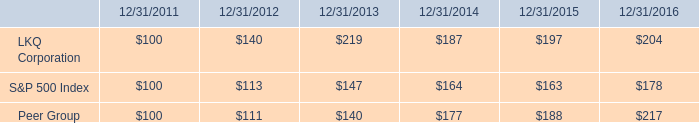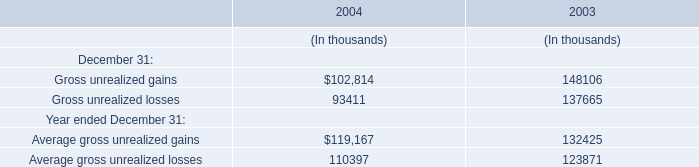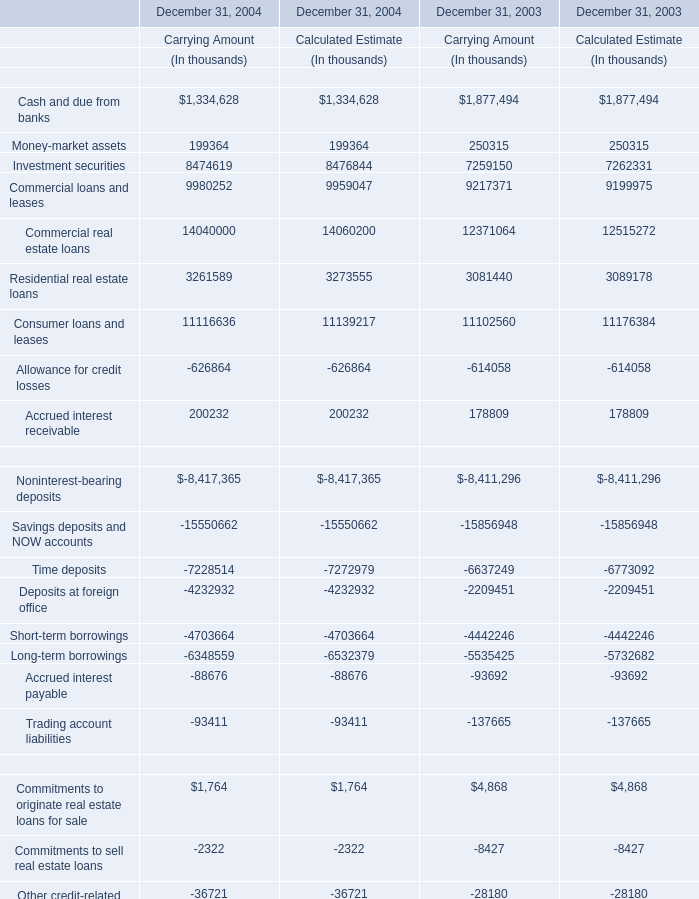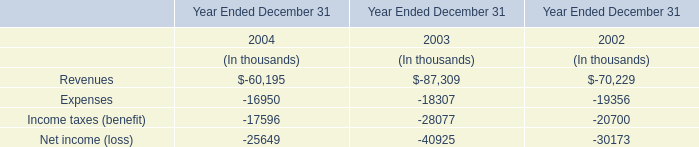What is the ratio of Accrued interest receivable of Carrying Amount in Table 2 to the Income taxes (benefit) in Table 3 in 2003? 
Computations: (178809 / -28077)
Answer: -6.36852. 